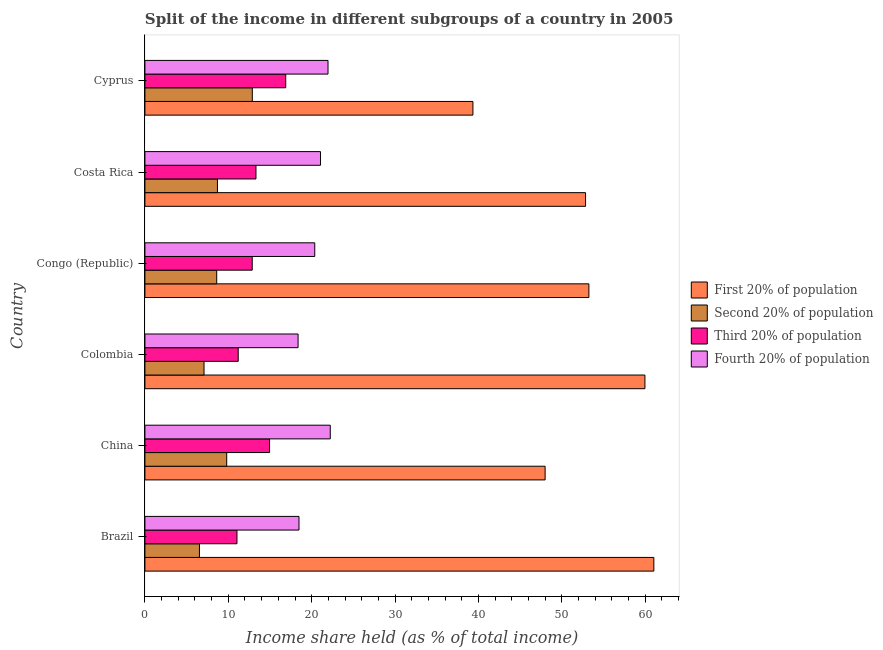How many groups of bars are there?
Provide a short and direct response. 6. How many bars are there on the 1st tick from the top?
Your answer should be very brief. 4. In how many cases, is the number of bars for a given country not equal to the number of legend labels?
Your response must be concise. 0. What is the share of the income held by second 20% of the population in Cyprus?
Your answer should be very brief. 12.88. Across all countries, what is the maximum share of the income held by third 20% of the population?
Keep it short and to the point. 16.89. Across all countries, what is the minimum share of the income held by first 20% of the population?
Offer a terse response. 39.34. In which country was the share of the income held by third 20% of the population maximum?
Offer a terse response. Cyprus. What is the total share of the income held by fourth 20% of the population in the graph?
Your response must be concise. 122.47. What is the difference between the share of the income held by first 20% of the population in Brazil and that in Congo (Republic)?
Your answer should be compact. 7.79. What is the difference between the share of the income held by fourth 20% of the population in Brazil and the share of the income held by second 20% of the population in Congo (Republic)?
Make the answer very short. 9.87. What is the average share of the income held by third 20% of the population per country?
Your answer should be compact. 13.38. What is the difference between the share of the income held by fourth 20% of the population and share of the income held by second 20% of the population in Brazil?
Your answer should be compact. 11.94. In how many countries, is the share of the income held by fourth 20% of the population greater than 8 %?
Offer a very short reply. 6. What is the ratio of the share of the income held by second 20% of the population in Brazil to that in Colombia?
Give a very brief answer. 0.92. Is the difference between the share of the income held by second 20% of the population in Colombia and Congo (Republic) greater than the difference between the share of the income held by fourth 20% of the population in Colombia and Congo (Republic)?
Offer a very short reply. Yes. What is the difference between the highest and the second highest share of the income held by fourth 20% of the population?
Offer a very short reply. 0.27. What is the difference between the highest and the lowest share of the income held by fourth 20% of the population?
Your answer should be very brief. 3.86. In how many countries, is the share of the income held by third 20% of the population greater than the average share of the income held by third 20% of the population taken over all countries?
Make the answer very short. 2. Is the sum of the share of the income held by fourth 20% of the population in China and Congo (Republic) greater than the maximum share of the income held by first 20% of the population across all countries?
Your response must be concise. No. What does the 3rd bar from the top in Colombia represents?
Your answer should be very brief. Second 20% of population. What does the 3rd bar from the bottom in China represents?
Keep it short and to the point. Third 20% of population. How many bars are there?
Provide a short and direct response. 24. What is the difference between two consecutive major ticks on the X-axis?
Offer a very short reply. 10. Does the graph contain any zero values?
Your response must be concise. No. What is the title of the graph?
Give a very brief answer. Split of the income in different subgroups of a country in 2005. Does "Taxes on exports" appear as one of the legend labels in the graph?
Keep it short and to the point. No. What is the label or title of the X-axis?
Make the answer very short. Income share held (as % of total income). What is the label or title of the Y-axis?
Your answer should be compact. Country. What is the Income share held (as % of total income) of First 20% of population in Brazil?
Keep it short and to the point. 61.04. What is the Income share held (as % of total income) of Second 20% of population in Brazil?
Offer a terse response. 6.54. What is the Income share held (as % of total income) in Third 20% of population in Brazil?
Your answer should be very brief. 11.04. What is the Income share held (as % of total income) in Fourth 20% of population in Brazil?
Offer a very short reply. 18.48. What is the Income share held (as % of total income) in First 20% of population in China?
Offer a very short reply. 48. What is the Income share held (as % of total income) in Second 20% of population in China?
Your response must be concise. 9.81. What is the Income share held (as % of total income) of Third 20% of population in China?
Your answer should be compact. 14.95. What is the Income share held (as % of total income) of Fourth 20% of population in China?
Your answer should be compact. 22.23. What is the Income share held (as % of total income) of First 20% of population in Colombia?
Offer a terse response. 59.97. What is the Income share held (as % of total income) of Second 20% of population in Colombia?
Offer a very short reply. 7.09. What is the Income share held (as % of total income) in Third 20% of population in Colombia?
Offer a very short reply. 11.19. What is the Income share held (as % of total income) of Fourth 20% of population in Colombia?
Your answer should be compact. 18.37. What is the Income share held (as % of total income) of First 20% of population in Congo (Republic)?
Provide a short and direct response. 53.25. What is the Income share held (as % of total income) of Second 20% of population in Congo (Republic)?
Offer a terse response. 8.61. What is the Income share held (as % of total income) in Third 20% of population in Congo (Republic)?
Offer a terse response. 12.87. What is the Income share held (as % of total income) in Fourth 20% of population in Congo (Republic)?
Your response must be concise. 20.37. What is the Income share held (as % of total income) in First 20% of population in Costa Rica?
Make the answer very short. 52.85. What is the Income share held (as % of total income) of Second 20% of population in Costa Rica?
Your response must be concise. 8.7. What is the Income share held (as % of total income) of Third 20% of population in Costa Rica?
Your answer should be compact. 13.32. What is the Income share held (as % of total income) of Fourth 20% of population in Costa Rica?
Make the answer very short. 21.06. What is the Income share held (as % of total income) of First 20% of population in Cyprus?
Your answer should be very brief. 39.34. What is the Income share held (as % of total income) of Second 20% of population in Cyprus?
Make the answer very short. 12.88. What is the Income share held (as % of total income) in Third 20% of population in Cyprus?
Provide a short and direct response. 16.89. What is the Income share held (as % of total income) in Fourth 20% of population in Cyprus?
Keep it short and to the point. 21.96. Across all countries, what is the maximum Income share held (as % of total income) of First 20% of population?
Keep it short and to the point. 61.04. Across all countries, what is the maximum Income share held (as % of total income) of Second 20% of population?
Your response must be concise. 12.88. Across all countries, what is the maximum Income share held (as % of total income) in Third 20% of population?
Offer a very short reply. 16.89. Across all countries, what is the maximum Income share held (as % of total income) in Fourth 20% of population?
Make the answer very short. 22.23. Across all countries, what is the minimum Income share held (as % of total income) of First 20% of population?
Offer a very short reply. 39.34. Across all countries, what is the minimum Income share held (as % of total income) of Second 20% of population?
Your answer should be compact. 6.54. Across all countries, what is the minimum Income share held (as % of total income) in Third 20% of population?
Provide a short and direct response. 11.04. Across all countries, what is the minimum Income share held (as % of total income) of Fourth 20% of population?
Offer a terse response. 18.37. What is the total Income share held (as % of total income) in First 20% of population in the graph?
Offer a terse response. 314.45. What is the total Income share held (as % of total income) in Second 20% of population in the graph?
Make the answer very short. 53.63. What is the total Income share held (as % of total income) of Third 20% of population in the graph?
Provide a succinct answer. 80.26. What is the total Income share held (as % of total income) of Fourth 20% of population in the graph?
Provide a short and direct response. 122.47. What is the difference between the Income share held (as % of total income) in First 20% of population in Brazil and that in China?
Ensure brevity in your answer.  13.04. What is the difference between the Income share held (as % of total income) of Second 20% of population in Brazil and that in China?
Your answer should be very brief. -3.27. What is the difference between the Income share held (as % of total income) in Third 20% of population in Brazil and that in China?
Your answer should be compact. -3.91. What is the difference between the Income share held (as % of total income) in Fourth 20% of population in Brazil and that in China?
Ensure brevity in your answer.  -3.75. What is the difference between the Income share held (as % of total income) in First 20% of population in Brazil and that in Colombia?
Give a very brief answer. 1.07. What is the difference between the Income share held (as % of total income) in Second 20% of population in Brazil and that in Colombia?
Your answer should be very brief. -0.55. What is the difference between the Income share held (as % of total income) of Fourth 20% of population in Brazil and that in Colombia?
Give a very brief answer. 0.11. What is the difference between the Income share held (as % of total income) of First 20% of population in Brazil and that in Congo (Republic)?
Provide a succinct answer. 7.79. What is the difference between the Income share held (as % of total income) of Second 20% of population in Brazil and that in Congo (Republic)?
Your answer should be compact. -2.07. What is the difference between the Income share held (as % of total income) of Third 20% of population in Brazil and that in Congo (Republic)?
Offer a terse response. -1.83. What is the difference between the Income share held (as % of total income) in Fourth 20% of population in Brazil and that in Congo (Republic)?
Offer a terse response. -1.89. What is the difference between the Income share held (as % of total income) in First 20% of population in Brazil and that in Costa Rica?
Your answer should be very brief. 8.19. What is the difference between the Income share held (as % of total income) in Second 20% of population in Brazil and that in Costa Rica?
Offer a very short reply. -2.16. What is the difference between the Income share held (as % of total income) of Third 20% of population in Brazil and that in Costa Rica?
Provide a short and direct response. -2.28. What is the difference between the Income share held (as % of total income) of Fourth 20% of population in Brazil and that in Costa Rica?
Provide a succinct answer. -2.58. What is the difference between the Income share held (as % of total income) of First 20% of population in Brazil and that in Cyprus?
Your answer should be very brief. 21.7. What is the difference between the Income share held (as % of total income) in Second 20% of population in Brazil and that in Cyprus?
Ensure brevity in your answer.  -6.34. What is the difference between the Income share held (as % of total income) of Third 20% of population in Brazil and that in Cyprus?
Provide a succinct answer. -5.85. What is the difference between the Income share held (as % of total income) in Fourth 20% of population in Brazil and that in Cyprus?
Offer a very short reply. -3.48. What is the difference between the Income share held (as % of total income) in First 20% of population in China and that in Colombia?
Ensure brevity in your answer.  -11.97. What is the difference between the Income share held (as % of total income) in Second 20% of population in China and that in Colombia?
Offer a terse response. 2.72. What is the difference between the Income share held (as % of total income) in Third 20% of population in China and that in Colombia?
Make the answer very short. 3.76. What is the difference between the Income share held (as % of total income) in Fourth 20% of population in China and that in Colombia?
Your answer should be compact. 3.86. What is the difference between the Income share held (as % of total income) of First 20% of population in China and that in Congo (Republic)?
Make the answer very short. -5.25. What is the difference between the Income share held (as % of total income) in Third 20% of population in China and that in Congo (Republic)?
Ensure brevity in your answer.  2.08. What is the difference between the Income share held (as % of total income) in Fourth 20% of population in China and that in Congo (Republic)?
Provide a succinct answer. 1.86. What is the difference between the Income share held (as % of total income) in First 20% of population in China and that in Costa Rica?
Make the answer very short. -4.85. What is the difference between the Income share held (as % of total income) of Second 20% of population in China and that in Costa Rica?
Provide a succinct answer. 1.11. What is the difference between the Income share held (as % of total income) of Third 20% of population in China and that in Costa Rica?
Make the answer very short. 1.63. What is the difference between the Income share held (as % of total income) in Fourth 20% of population in China and that in Costa Rica?
Provide a succinct answer. 1.17. What is the difference between the Income share held (as % of total income) in First 20% of population in China and that in Cyprus?
Make the answer very short. 8.66. What is the difference between the Income share held (as % of total income) of Second 20% of population in China and that in Cyprus?
Your answer should be compact. -3.07. What is the difference between the Income share held (as % of total income) in Third 20% of population in China and that in Cyprus?
Your answer should be very brief. -1.94. What is the difference between the Income share held (as % of total income) of Fourth 20% of population in China and that in Cyprus?
Ensure brevity in your answer.  0.27. What is the difference between the Income share held (as % of total income) in First 20% of population in Colombia and that in Congo (Republic)?
Offer a very short reply. 6.72. What is the difference between the Income share held (as % of total income) in Second 20% of population in Colombia and that in Congo (Republic)?
Your answer should be very brief. -1.52. What is the difference between the Income share held (as % of total income) in Third 20% of population in Colombia and that in Congo (Republic)?
Provide a succinct answer. -1.68. What is the difference between the Income share held (as % of total income) in First 20% of population in Colombia and that in Costa Rica?
Your answer should be very brief. 7.12. What is the difference between the Income share held (as % of total income) in Second 20% of population in Colombia and that in Costa Rica?
Provide a short and direct response. -1.61. What is the difference between the Income share held (as % of total income) of Third 20% of population in Colombia and that in Costa Rica?
Offer a very short reply. -2.13. What is the difference between the Income share held (as % of total income) of Fourth 20% of population in Colombia and that in Costa Rica?
Provide a succinct answer. -2.69. What is the difference between the Income share held (as % of total income) in First 20% of population in Colombia and that in Cyprus?
Your answer should be compact. 20.63. What is the difference between the Income share held (as % of total income) in Second 20% of population in Colombia and that in Cyprus?
Provide a short and direct response. -5.79. What is the difference between the Income share held (as % of total income) in Third 20% of population in Colombia and that in Cyprus?
Give a very brief answer. -5.7. What is the difference between the Income share held (as % of total income) of Fourth 20% of population in Colombia and that in Cyprus?
Ensure brevity in your answer.  -3.59. What is the difference between the Income share held (as % of total income) of Second 20% of population in Congo (Republic) and that in Costa Rica?
Your answer should be very brief. -0.09. What is the difference between the Income share held (as % of total income) of Third 20% of population in Congo (Republic) and that in Costa Rica?
Offer a terse response. -0.45. What is the difference between the Income share held (as % of total income) in Fourth 20% of population in Congo (Republic) and that in Costa Rica?
Offer a terse response. -0.69. What is the difference between the Income share held (as % of total income) of First 20% of population in Congo (Republic) and that in Cyprus?
Offer a very short reply. 13.91. What is the difference between the Income share held (as % of total income) of Second 20% of population in Congo (Republic) and that in Cyprus?
Your answer should be very brief. -4.27. What is the difference between the Income share held (as % of total income) in Third 20% of population in Congo (Republic) and that in Cyprus?
Ensure brevity in your answer.  -4.02. What is the difference between the Income share held (as % of total income) of Fourth 20% of population in Congo (Republic) and that in Cyprus?
Make the answer very short. -1.59. What is the difference between the Income share held (as % of total income) in First 20% of population in Costa Rica and that in Cyprus?
Offer a terse response. 13.51. What is the difference between the Income share held (as % of total income) in Second 20% of population in Costa Rica and that in Cyprus?
Offer a terse response. -4.18. What is the difference between the Income share held (as % of total income) of Third 20% of population in Costa Rica and that in Cyprus?
Keep it short and to the point. -3.57. What is the difference between the Income share held (as % of total income) of First 20% of population in Brazil and the Income share held (as % of total income) of Second 20% of population in China?
Give a very brief answer. 51.23. What is the difference between the Income share held (as % of total income) in First 20% of population in Brazil and the Income share held (as % of total income) in Third 20% of population in China?
Your answer should be very brief. 46.09. What is the difference between the Income share held (as % of total income) of First 20% of population in Brazil and the Income share held (as % of total income) of Fourth 20% of population in China?
Offer a very short reply. 38.81. What is the difference between the Income share held (as % of total income) of Second 20% of population in Brazil and the Income share held (as % of total income) of Third 20% of population in China?
Provide a short and direct response. -8.41. What is the difference between the Income share held (as % of total income) in Second 20% of population in Brazil and the Income share held (as % of total income) in Fourth 20% of population in China?
Ensure brevity in your answer.  -15.69. What is the difference between the Income share held (as % of total income) of Third 20% of population in Brazil and the Income share held (as % of total income) of Fourth 20% of population in China?
Your answer should be compact. -11.19. What is the difference between the Income share held (as % of total income) of First 20% of population in Brazil and the Income share held (as % of total income) of Second 20% of population in Colombia?
Keep it short and to the point. 53.95. What is the difference between the Income share held (as % of total income) of First 20% of population in Brazil and the Income share held (as % of total income) of Third 20% of population in Colombia?
Your answer should be very brief. 49.85. What is the difference between the Income share held (as % of total income) in First 20% of population in Brazil and the Income share held (as % of total income) in Fourth 20% of population in Colombia?
Offer a terse response. 42.67. What is the difference between the Income share held (as % of total income) of Second 20% of population in Brazil and the Income share held (as % of total income) of Third 20% of population in Colombia?
Provide a succinct answer. -4.65. What is the difference between the Income share held (as % of total income) of Second 20% of population in Brazil and the Income share held (as % of total income) of Fourth 20% of population in Colombia?
Make the answer very short. -11.83. What is the difference between the Income share held (as % of total income) of Third 20% of population in Brazil and the Income share held (as % of total income) of Fourth 20% of population in Colombia?
Make the answer very short. -7.33. What is the difference between the Income share held (as % of total income) in First 20% of population in Brazil and the Income share held (as % of total income) in Second 20% of population in Congo (Republic)?
Keep it short and to the point. 52.43. What is the difference between the Income share held (as % of total income) in First 20% of population in Brazil and the Income share held (as % of total income) in Third 20% of population in Congo (Republic)?
Provide a short and direct response. 48.17. What is the difference between the Income share held (as % of total income) in First 20% of population in Brazil and the Income share held (as % of total income) in Fourth 20% of population in Congo (Republic)?
Your response must be concise. 40.67. What is the difference between the Income share held (as % of total income) of Second 20% of population in Brazil and the Income share held (as % of total income) of Third 20% of population in Congo (Republic)?
Ensure brevity in your answer.  -6.33. What is the difference between the Income share held (as % of total income) in Second 20% of population in Brazil and the Income share held (as % of total income) in Fourth 20% of population in Congo (Republic)?
Offer a terse response. -13.83. What is the difference between the Income share held (as % of total income) of Third 20% of population in Brazil and the Income share held (as % of total income) of Fourth 20% of population in Congo (Republic)?
Provide a short and direct response. -9.33. What is the difference between the Income share held (as % of total income) of First 20% of population in Brazil and the Income share held (as % of total income) of Second 20% of population in Costa Rica?
Your response must be concise. 52.34. What is the difference between the Income share held (as % of total income) in First 20% of population in Brazil and the Income share held (as % of total income) in Third 20% of population in Costa Rica?
Make the answer very short. 47.72. What is the difference between the Income share held (as % of total income) of First 20% of population in Brazil and the Income share held (as % of total income) of Fourth 20% of population in Costa Rica?
Ensure brevity in your answer.  39.98. What is the difference between the Income share held (as % of total income) of Second 20% of population in Brazil and the Income share held (as % of total income) of Third 20% of population in Costa Rica?
Your answer should be compact. -6.78. What is the difference between the Income share held (as % of total income) of Second 20% of population in Brazil and the Income share held (as % of total income) of Fourth 20% of population in Costa Rica?
Your response must be concise. -14.52. What is the difference between the Income share held (as % of total income) of Third 20% of population in Brazil and the Income share held (as % of total income) of Fourth 20% of population in Costa Rica?
Your answer should be compact. -10.02. What is the difference between the Income share held (as % of total income) in First 20% of population in Brazil and the Income share held (as % of total income) in Second 20% of population in Cyprus?
Make the answer very short. 48.16. What is the difference between the Income share held (as % of total income) in First 20% of population in Brazil and the Income share held (as % of total income) in Third 20% of population in Cyprus?
Your answer should be very brief. 44.15. What is the difference between the Income share held (as % of total income) of First 20% of population in Brazil and the Income share held (as % of total income) of Fourth 20% of population in Cyprus?
Your response must be concise. 39.08. What is the difference between the Income share held (as % of total income) of Second 20% of population in Brazil and the Income share held (as % of total income) of Third 20% of population in Cyprus?
Keep it short and to the point. -10.35. What is the difference between the Income share held (as % of total income) in Second 20% of population in Brazil and the Income share held (as % of total income) in Fourth 20% of population in Cyprus?
Your answer should be compact. -15.42. What is the difference between the Income share held (as % of total income) of Third 20% of population in Brazil and the Income share held (as % of total income) of Fourth 20% of population in Cyprus?
Give a very brief answer. -10.92. What is the difference between the Income share held (as % of total income) of First 20% of population in China and the Income share held (as % of total income) of Second 20% of population in Colombia?
Offer a very short reply. 40.91. What is the difference between the Income share held (as % of total income) of First 20% of population in China and the Income share held (as % of total income) of Third 20% of population in Colombia?
Give a very brief answer. 36.81. What is the difference between the Income share held (as % of total income) in First 20% of population in China and the Income share held (as % of total income) in Fourth 20% of population in Colombia?
Your answer should be compact. 29.63. What is the difference between the Income share held (as % of total income) of Second 20% of population in China and the Income share held (as % of total income) of Third 20% of population in Colombia?
Provide a succinct answer. -1.38. What is the difference between the Income share held (as % of total income) of Second 20% of population in China and the Income share held (as % of total income) of Fourth 20% of population in Colombia?
Provide a short and direct response. -8.56. What is the difference between the Income share held (as % of total income) in Third 20% of population in China and the Income share held (as % of total income) in Fourth 20% of population in Colombia?
Make the answer very short. -3.42. What is the difference between the Income share held (as % of total income) of First 20% of population in China and the Income share held (as % of total income) of Second 20% of population in Congo (Republic)?
Your answer should be very brief. 39.39. What is the difference between the Income share held (as % of total income) of First 20% of population in China and the Income share held (as % of total income) of Third 20% of population in Congo (Republic)?
Keep it short and to the point. 35.13. What is the difference between the Income share held (as % of total income) of First 20% of population in China and the Income share held (as % of total income) of Fourth 20% of population in Congo (Republic)?
Give a very brief answer. 27.63. What is the difference between the Income share held (as % of total income) in Second 20% of population in China and the Income share held (as % of total income) in Third 20% of population in Congo (Republic)?
Your answer should be compact. -3.06. What is the difference between the Income share held (as % of total income) in Second 20% of population in China and the Income share held (as % of total income) in Fourth 20% of population in Congo (Republic)?
Make the answer very short. -10.56. What is the difference between the Income share held (as % of total income) of Third 20% of population in China and the Income share held (as % of total income) of Fourth 20% of population in Congo (Republic)?
Make the answer very short. -5.42. What is the difference between the Income share held (as % of total income) of First 20% of population in China and the Income share held (as % of total income) of Second 20% of population in Costa Rica?
Your response must be concise. 39.3. What is the difference between the Income share held (as % of total income) of First 20% of population in China and the Income share held (as % of total income) of Third 20% of population in Costa Rica?
Your response must be concise. 34.68. What is the difference between the Income share held (as % of total income) in First 20% of population in China and the Income share held (as % of total income) in Fourth 20% of population in Costa Rica?
Offer a terse response. 26.94. What is the difference between the Income share held (as % of total income) in Second 20% of population in China and the Income share held (as % of total income) in Third 20% of population in Costa Rica?
Make the answer very short. -3.51. What is the difference between the Income share held (as % of total income) of Second 20% of population in China and the Income share held (as % of total income) of Fourth 20% of population in Costa Rica?
Give a very brief answer. -11.25. What is the difference between the Income share held (as % of total income) in Third 20% of population in China and the Income share held (as % of total income) in Fourth 20% of population in Costa Rica?
Provide a succinct answer. -6.11. What is the difference between the Income share held (as % of total income) in First 20% of population in China and the Income share held (as % of total income) in Second 20% of population in Cyprus?
Make the answer very short. 35.12. What is the difference between the Income share held (as % of total income) in First 20% of population in China and the Income share held (as % of total income) in Third 20% of population in Cyprus?
Your answer should be very brief. 31.11. What is the difference between the Income share held (as % of total income) in First 20% of population in China and the Income share held (as % of total income) in Fourth 20% of population in Cyprus?
Offer a very short reply. 26.04. What is the difference between the Income share held (as % of total income) of Second 20% of population in China and the Income share held (as % of total income) of Third 20% of population in Cyprus?
Keep it short and to the point. -7.08. What is the difference between the Income share held (as % of total income) in Second 20% of population in China and the Income share held (as % of total income) in Fourth 20% of population in Cyprus?
Offer a very short reply. -12.15. What is the difference between the Income share held (as % of total income) of Third 20% of population in China and the Income share held (as % of total income) of Fourth 20% of population in Cyprus?
Provide a short and direct response. -7.01. What is the difference between the Income share held (as % of total income) of First 20% of population in Colombia and the Income share held (as % of total income) of Second 20% of population in Congo (Republic)?
Give a very brief answer. 51.36. What is the difference between the Income share held (as % of total income) in First 20% of population in Colombia and the Income share held (as % of total income) in Third 20% of population in Congo (Republic)?
Keep it short and to the point. 47.1. What is the difference between the Income share held (as % of total income) of First 20% of population in Colombia and the Income share held (as % of total income) of Fourth 20% of population in Congo (Republic)?
Your response must be concise. 39.6. What is the difference between the Income share held (as % of total income) of Second 20% of population in Colombia and the Income share held (as % of total income) of Third 20% of population in Congo (Republic)?
Your response must be concise. -5.78. What is the difference between the Income share held (as % of total income) of Second 20% of population in Colombia and the Income share held (as % of total income) of Fourth 20% of population in Congo (Republic)?
Offer a very short reply. -13.28. What is the difference between the Income share held (as % of total income) in Third 20% of population in Colombia and the Income share held (as % of total income) in Fourth 20% of population in Congo (Republic)?
Keep it short and to the point. -9.18. What is the difference between the Income share held (as % of total income) in First 20% of population in Colombia and the Income share held (as % of total income) in Second 20% of population in Costa Rica?
Your answer should be very brief. 51.27. What is the difference between the Income share held (as % of total income) of First 20% of population in Colombia and the Income share held (as % of total income) of Third 20% of population in Costa Rica?
Provide a short and direct response. 46.65. What is the difference between the Income share held (as % of total income) of First 20% of population in Colombia and the Income share held (as % of total income) of Fourth 20% of population in Costa Rica?
Offer a very short reply. 38.91. What is the difference between the Income share held (as % of total income) of Second 20% of population in Colombia and the Income share held (as % of total income) of Third 20% of population in Costa Rica?
Ensure brevity in your answer.  -6.23. What is the difference between the Income share held (as % of total income) in Second 20% of population in Colombia and the Income share held (as % of total income) in Fourth 20% of population in Costa Rica?
Your answer should be very brief. -13.97. What is the difference between the Income share held (as % of total income) of Third 20% of population in Colombia and the Income share held (as % of total income) of Fourth 20% of population in Costa Rica?
Your response must be concise. -9.87. What is the difference between the Income share held (as % of total income) in First 20% of population in Colombia and the Income share held (as % of total income) in Second 20% of population in Cyprus?
Keep it short and to the point. 47.09. What is the difference between the Income share held (as % of total income) in First 20% of population in Colombia and the Income share held (as % of total income) in Third 20% of population in Cyprus?
Your response must be concise. 43.08. What is the difference between the Income share held (as % of total income) of First 20% of population in Colombia and the Income share held (as % of total income) of Fourth 20% of population in Cyprus?
Provide a short and direct response. 38.01. What is the difference between the Income share held (as % of total income) of Second 20% of population in Colombia and the Income share held (as % of total income) of Fourth 20% of population in Cyprus?
Provide a succinct answer. -14.87. What is the difference between the Income share held (as % of total income) of Third 20% of population in Colombia and the Income share held (as % of total income) of Fourth 20% of population in Cyprus?
Offer a terse response. -10.77. What is the difference between the Income share held (as % of total income) of First 20% of population in Congo (Republic) and the Income share held (as % of total income) of Second 20% of population in Costa Rica?
Your response must be concise. 44.55. What is the difference between the Income share held (as % of total income) in First 20% of population in Congo (Republic) and the Income share held (as % of total income) in Third 20% of population in Costa Rica?
Your answer should be compact. 39.93. What is the difference between the Income share held (as % of total income) of First 20% of population in Congo (Republic) and the Income share held (as % of total income) of Fourth 20% of population in Costa Rica?
Your answer should be very brief. 32.19. What is the difference between the Income share held (as % of total income) in Second 20% of population in Congo (Republic) and the Income share held (as % of total income) in Third 20% of population in Costa Rica?
Offer a terse response. -4.71. What is the difference between the Income share held (as % of total income) of Second 20% of population in Congo (Republic) and the Income share held (as % of total income) of Fourth 20% of population in Costa Rica?
Offer a very short reply. -12.45. What is the difference between the Income share held (as % of total income) in Third 20% of population in Congo (Republic) and the Income share held (as % of total income) in Fourth 20% of population in Costa Rica?
Offer a terse response. -8.19. What is the difference between the Income share held (as % of total income) in First 20% of population in Congo (Republic) and the Income share held (as % of total income) in Second 20% of population in Cyprus?
Your answer should be compact. 40.37. What is the difference between the Income share held (as % of total income) in First 20% of population in Congo (Republic) and the Income share held (as % of total income) in Third 20% of population in Cyprus?
Provide a short and direct response. 36.36. What is the difference between the Income share held (as % of total income) in First 20% of population in Congo (Republic) and the Income share held (as % of total income) in Fourth 20% of population in Cyprus?
Make the answer very short. 31.29. What is the difference between the Income share held (as % of total income) of Second 20% of population in Congo (Republic) and the Income share held (as % of total income) of Third 20% of population in Cyprus?
Offer a very short reply. -8.28. What is the difference between the Income share held (as % of total income) in Second 20% of population in Congo (Republic) and the Income share held (as % of total income) in Fourth 20% of population in Cyprus?
Offer a very short reply. -13.35. What is the difference between the Income share held (as % of total income) of Third 20% of population in Congo (Republic) and the Income share held (as % of total income) of Fourth 20% of population in Cyprus?
Your answer should be very brief. -9.09. What is the difference between the Income share held (as % of total income) of First 20% of population in Costa Rica and the Income share held (as % of total income) of Second 20% of population in Cyprus?
Your response must be concise. 39.97. What is the difference between the Income share held (as % of total income) in First 20% of population in Costa Rica and the Income share held (as % of total income) in Third 20% of population in Cyprus?
Your response must be concise. 35.96. What is the difference between the Income share held (as % of total income) of First 20% of population in Costa Rica and the Income share held (as % of total income) of Fourth 20% of population in Cyprus?
Make the answer very short. 30.89. What is the difference between the Income share held (as % of total income) of Second 20% of population in Costa Rica and the Income share held (as % of total income) of Third 20% of population in Cyprus?
Ensure brevity in your answer.  -8.19. What is the difference between the Income share held (as % of total income) in Second 20% of population in Costa Rica and the Income share held (as % of total income) in Fourth 20% of population in Cyprus?
Offer a very short reply. -13.26. What is the difference between the Income share held (as % of total income) of Third 20% of population in Costa Rica and the Income share held (as % of total income) of Fourth 20% of population in Cyprus?
Offer a very short reply. -8.64. What is the average Income share held (as % of total income) of First 20% of population per country?
Offer a terse response. 52.41. What is the average Income share held (as % of total income) of Second 20% of population per country?
Provide a succinct answer. 8.94. What is the average Income share held (as % of total income) in Third 20% of population per country?
Keep it short and to the point. 13.38. What is the average Income share held (as % of total income) in Fourth 20% of population per country?
Your answer should be very brief. 20.41. What is the difference between the Income share held (as % of total income) in First 20% of population and Income share held (as % of total income) in Second 20% of population in Brazil?
Keep it short and to the point. 54.5. What is the difference between the Income share held (as % of total income) in First 20% of population and Income share held (as % of total income) in Third 20% of population in Brazil?
Your answer should be very brief. 50. What is the difference between the Income share held (as % of total income) of First 20% of population and Income share held (as % of total income) of Fourth 20% of population in Brazil?
Your response must be concise. 42.56. What is the difference between the Income share held (as % of total income) of Second 20% of population and Income share held (as % of total income) of Third 20% of population in Brazil?
Provide a succinct answer. -4.5. What is the difference between the Income share held (as % of total income) in Second 20% of population and Income share held (as % of total income) in Fourth 20% of population in Brazil?
Offer a very short reply. -11.94. What is the difference between the Income share held (as % of total income) in Third 20% of population and Income share held (as % of total income) in Fourth 20% of population in Brazil?
Offer a very short reply. -7.44. What is the difference between the Income share held (as % of total income) of First 20% of population and Income share held (as % of total income) of Second 20% of population in China?
Your answer should be compact. 38.19. What is the difference between the Income share held (as % of total income) of First 20% of population and Income share held (as % of total income) of Third 20% of population in China?
Provide a short and direct response. 33.05. What is the difference between the Income share held (as % of total income) in First 20% of population and Income share held (as % of total income) in Fourth 20% of population in China?
Your answer should be very brief. 25.77. What is the difference between the Income share held (as % of total income) in Second 20% of population and Income share held (as % of total income) in Third 20% of population in China?
Offer a terse response. -5.14. What is the difference between the Income share held (as % of total income) in Second 20% of population and Income share held (as % of total income) in Fourth 20% of population in China?
Your answer should be very brief. -12.42. What is the difference between the Income share held (as % of total income) of Third 20% of population and Income share held (as % of total income) of Fourth 20% of population in China?
Your answer should be compact. -7.28. What is the difference between the Income share held (as % of total income) in First 20% of population and Income share held (as % of total income) in Second 20% of population in Colombia?
Your answer should be compact. 52.88. What is the difference between the Income share held (as % of total income) of First 20% of population and Income share held (as % of total income) of Third 20% of population in Colombia?
Your answer should be very brief. 48.78. What is the difference between the Income share held (as % of total income) of First 20% of population and Income share held (as % of total income) of Fourth 20% of population in Colombia?
Your answer should be very brief. 41.6. What is the difference between the Income share held (as % of total income) of Second 20% of population and Income share held (as % of total income) of Third 20% of population in Colombia?
Make the answer very short. -4.1. What is the difference between the Income share held (as % of total income) in Second 20% of population and Income share held (as % of total income) in Fourth 20% of population in Colombia?
Your response must be concise. -11.28. What is the difference between the Income share held (as % of total income) of Third 20% of population and Income share held (as % of total income) of Fourth 20% of population in Colombia?
Give a very brief answer. -7.18. What is the difference between the Income share held (as % of total income) of First 20% of population and Income share held (as % of total income) of Second 20% of population in Congo (Republic)?
Ensure brevity in your answer.  44.64. What is the difference between the Income share held (as % of total income) in First 20% of population and Income share held (as % of total income) in Third 20% of population in Congo (Republic)?
Offer a very short reply. 40.38. What is the difference between the Income share held (as % of total income) in First 20% of population and Income share held (as % of total income) in Fourth 20% of population in Congo (Republic)?
Provide a succinct answer. 32.88. What is the difference between the Income share held (as % of total income) of Second 20% of population and Income share held (as % of total income) of Third 20% of population in Congo (Republic)?
Offer a terse response. -4.26. What is the difference between the Income share held (as % of total income) in Second 20% of population and Income share held (as % of total income) in Fourth 20% of population in Congo (Republic)?
Offer a very short reply. -11.76. What is the difference between the Income share held (as % of total income) of First 20% of population and Income share held (as % of total income) of Second 20% of population in Costa Rica?
Keep it short and to the point. 44.15. What is the difference between the Income share held (as % of total income) of First 20% of population and Income share held (as % of total income) of Third 20% of population in Costa Rica?
Your response must be concise. 39.53. What is the difference between the Income share held (as % of total income) of First 20% of population and Income share held (as % of total income) of Fourth 20% of population in Costa Rica?
Offer a terse response. 31.79. What is the difference between the Income share held (as % of total income) of Second 20% of population and Income share held (as % of total income) of Third 20% of population in Costa Rica?
Provide a succinct answer. -4.62. What is the difference between the Income share held (as % of total income) of Second 20% of population and Income share held (as % of total income) of Fourth 20% of population in Costa Rica?
Give a very brief answer. -12.36. What is the difference between the Income share held (as % of total income) of Third 20% of population and Income share held (as % of total income) of Fourth 20% of population in Costa Rica?
Make the answer very short. -7.74. What is the difference between the Income share held (as % of total income) of First 20% of population and Income share held (as % of total income) of Second 20% of population in Cyprus?
Offer a terse response. 26.46. What is the difference between the Income share held (as % of total income) of First 20% of population and Income share held (as % of total income) of Third 20% of population in Cyprus?
Make the answer very short. 22.45. What is the difference between the Income share held (as % of total income) in First 20% of population and Income share held (as % of total income) in Fourth 20% of population in Cyprus?
Provide a short and direct response. 17.38. What is the difference between the Income share held (as % of total income) of Second 20% of population and Income share held (as % of total income) of Third 20% of population in Cyprus?
Provide a succinct answer. -4.01. What is the difference between the Income share held (as % of total income) of Second 20% of population and Income share held (as % of total income) of Fourth 20% of population in Cyprus?
Offer a very short reply. -9.08. What is the difference between the Income share held (as % of total income) of Third 20% of population and Income share held (as % of total income) of Fourth 20% of population in Cyprus?
Provide a short and direct response. -5.07. What is the ratio of the Income share held (as % of total income) in First 20% of population in Brazil to that in China?
Give a very brief answer. 1.27. What is the ratio of the Income share held (as % of total income) in Second 20% of population in Brazil to that in China?
Provide a succinct answer. 0.67. What is the ratio of the Income share held (as % of total income) in Third 20% of population in Brazil to that in China?
Ensure brevity in your answer.  0.74. What is the ratio of the Income share held (as % of total income) in Fourth 20% of population in Brazil to that in China?
Your response must be concise. 0.83. What is the ratio of the Income share held (as % of total income) of First 20% of population in Brazil to that in Colombia?
Provide a succinct answer. 1.02. What is the ratio of the Income share held (as % of total income) in Second 20% of population in Brazil to that in Colombia?
Your answer should be very brief. 0.92. What is the ratio of the Income share held (as % of total income) of Third 20% of population in Brazil to that in Colombia?
Give a very brief answer. 0.99. What is the ratio of the Income share held (as % of total income) in Fourth 20% of population in Brazil to that in Colombia?
Make the answer very short. 1.01. What is the ratio of the Income share held (as % of total income) in First 20% of population in Brazil to that in Congo (Republic)?
Provide a succinct answer. 1.15. What is the ratio of the Income share held (as % of total income) of Second 20% of population in Brazil to that in Congo (Republic)?
Keep it short and to the point. 0.76. What is the ratio of the Income share held (as % of total income) of Third 20% of population in Brazil to that in Congo (Republic)?
Your answer should be compact. 0.86. What is the ratio of the Income share held (as % of total income) in Fourth 20% of population in Brazil to that in Congo (Republic)?
Your answer should be compact. 0.91. What is the ratio of the Income share held (as % of total income) in First 20% of population in Brazil to that in Costa Rica?
Keep it short and to the point. 1.16. What is the ratio of the Income share held (as % of total income) of Second 20% of population in Brazil to that in Costa Rica?
Your response must be concise. 0.75. What is the ratio of the Income share held (as % of total income) in Third 20% of population in Brazil to that in Costa Rica?
Provide a succinct answer. 0.83. What is the ratio of the Income share held (as % of total income) in Fourth 20% of population in Brazil to that in Costa Rica?
Your answer should be very brief. 0.88. What is the ratio of the Income share held (as % of total income) in First 20% of population in Brazil to that in Cyprus?
Offer a terse response. 1.55. What is the ratio of the Income share held (as % of total income) of Second 20% of population in Brazil to that in Cyprus?
Provide a short and direct response. 0.51. What is the ratio of the Income share held (as % of total income) in Third 20% of population in Brazil to that in Cyprus?
Keep it short and to the point. 0.65. What is the ratio of the Income share held (as % of total income) in Fourth 20% of population in Brazil to that in Cyprus?
Keep it short and to the point. 0.84. What is the ratio of the Income share held (as % of total income) of First 20% of population in China to that in Colombia?
Your response must be concise. 0.8. What is the ratio of the Income share held (as % of total income) in Second 20% of population in China to that in Colombia?
Keep it short and to the point. 1.38. What is the ratio of the Income share held (as % of total income) in Third 20% of population in China to that in Colombia?
Keep it short and to the point. 1.34. What is the ratio of the Income share held (as % of total income) in Fourth 20% of population in China to that in Colombia?
Your response must be concise. 1.21. What is the ratio of the Income share held (as % of total income) of First 20% of population in China to that in Congo (Republic)?
Offer a very short reply. 0.9. What is the ratio of the Income share held (as % of total income) of Second 20% of population in China to that in Congo (Republic)?
Ensure brevity in your answer.  1.14. What is the ratio of the Income share held (as % of total income) in Third 20% of population in China to that in Congo (Republic)?
Give a very brief answer. 1.16. What is the ratio of the Income share held (as % of total income) of Fourth 20% of population in China to that in Congo (Republic)?
Provide a short and direct response. 1.09. What is the ratio of the Income share held (as % of total income) of First 20% of population in China to that in Costa Rica?
Your response must be concise. 0.91. What is the ratio of the Income share held (as % of total income) of Second 20% of population in China to that in Costa Rica?
Keep it short and to the point. 1.13. What is the ratio of the Income share held (as % of total income) in Third 20% of population in China to that in Costa Rica?
Offer a terse response. 1.12. What is the ratio of the Income share held (as % of total income) of Fourth 20% of population in China to that in Costa Rica?
Keep it short and to the point. 1.06. What is the ratio of the Income share held (as % of total income) of First 20% of population in China to that in Cyprus?
Your answer should be very brief. 1.22. What is the ratio of the Income share held (as % of total income) of Second 20% of population in China to that in Cyprus?
Your response must be concise. 0.76. What is the ratio of the Income share held (as % of total income) in Third 20% of population in China to that in Cyprus?
Make the answer very short. 0.89. What is the ratio of the Income share held (as % of total income) of Fourth 20% of population in China to that in Cyprus?
Your answer should be compact. 1.01. What is the ratio of the Income share held (as % of total income) of First 20% of population in Colombia to that in Congo (Republic)?
Provide a succinct answer. 1.13. What is the ratio of the Income share held (as % of total income) in Second 20% of population in Colombia to that in Congo (Republic)?
Make the answer very short. 0.82. What is the ratio of the Income share held (as % of total income) of Third 20% of population in Colombia to that in Congo (Republic)?
Your response must be concise. 0.87. What is the ratio of the Income share held (as % of total income) in Fourth 20% of population in Colombia to that in Congo (Republic)?
Give a very brief answer. 0.9. What is the ratio of the Income share held (as % of total income) in First 20% of population in Colombia to that in Costa Rica?
Give a very brief answer. 1.13. What is the ratio of the Income share held (as % of total income) in Second 20% of population in Colombia to that in Costa Rica?
Make the answer very short. 0.81. What is the ratio of the Income share held (as % of total income) of Third 20% of population in Colombia to that in Costa Rica?
Your response must be concise. 0.84. What is the ratio of the Income share held (as % of total income) of Fourth 20% of population in Colombia to that in Costa Rica?
Offer a very short reply. 0.87. What is the ratio of the Income share held (as % of total income) in First 20% of population in Colombia to that in Cyprus?
Your answer should be very brief. 1.52. What is the ratio of the Income share held (as % of total income) of Second 20% of population in Colombia to that in Cyprus?
Keep it short and to the point. 0.55. What is the ratio of the Income share held (as % of total income) of Third 20% of population in Colombia to that in Cyprus?
Make the answer very short. 0.66. What is the ratio of the Income share held (as % of total income) of Fourth 20% of population in Colombia to that in Cyprus?
Keep it short and to the point. 0.84. What is the ratio of the Income share held (as % of total income) of First 20% of population in Congo (Republic) to that in Costa Rica?
Give a very brief answer. 1.01. What is the ratio of the Income share held (as % of total income) of Second 20% of population in Congo (Republic) to that in Costa Rica?
Your answer should be compact. 0.99. What is the ratio of the Income share held (as % of total income) of Third 20% of population in Congo (Republic) to that in Costa Rica?
Offer a terse response. 0.97. What is the ratio of the Income share held (as % of total income) in Fourth 20% of population in Congo (Republic) to that in Costa Rica?
Your answer should be compact. 0.97. What is the ratio of the Income share held (as % of total income) in First 20% of population in Congo (Republic) to that in Cyprus?
Offer a terse response. 1.35. What is the ratio of the Income share held (as % of total income) in Second 20% of population in Congo (Republic) to that in Cyprus?
Your answer should be very brief. 0.67. What is the ratio of the Income share held (as % of total income) in Third 20% of population in Congo (Republic) to that in Cyprus?
Offer a very short reply. 0.76. What is the ratio of the Income share held (as % of total income) in Fourth 20% of population in Congo (Republic) to that in Cyprus?
Your answer should be very brief. 0.93. What is the ratio of the Income share held (as % of total income) of First 20% of population in Costa Rica to that in Cyprus?
Make the answer very short. 1.34. What is the ratio of the Income share held (as % of total income) of Second 20% of population in Costa Rica to that in Cyprus?
Offer a very short reply. 0.68. What is the ratio of the Income share held (as % of total income) of Third 20% of population in Costa Rica to that in Cyprus?
Your response must be concise. 0.79. What is the difference between the highest and the second highest Income share held (as % of total income) of First 20% of population?
Offer a terse response. 1.07. What is the difference between the highest and the second highest Income share held (as % of total income) of Second 20% of population?
Offer a very short reply. 3.07. What is the difference between the highest and the second highest Income share held (as % of total income) in Third 20% of population?
Give a very brief answer. 1.94. What is the difference between the highest and the second highest Income share held (as % of total income) in Fourth 20% of population?
Your answer should be compact. 0.27. What is the difference between the highest and the lowest Income share held (as % of total income) in First 20% of population?
Give a very brief answer. 21.7. What is the difference between the highest and the lowest Income share held (as % of total income) of Second 20% of population?
Your answer should be compact. 6.34. What is the difference between the highest and the lowest Income share held (as % of total income) of Third 20% of population?
Your answer should be compact. 5.85. What is the difference between the highest and the lowest Income share held (as % of total income) of Fourth 20% of population?
Your answer should be compact. 3.86. 